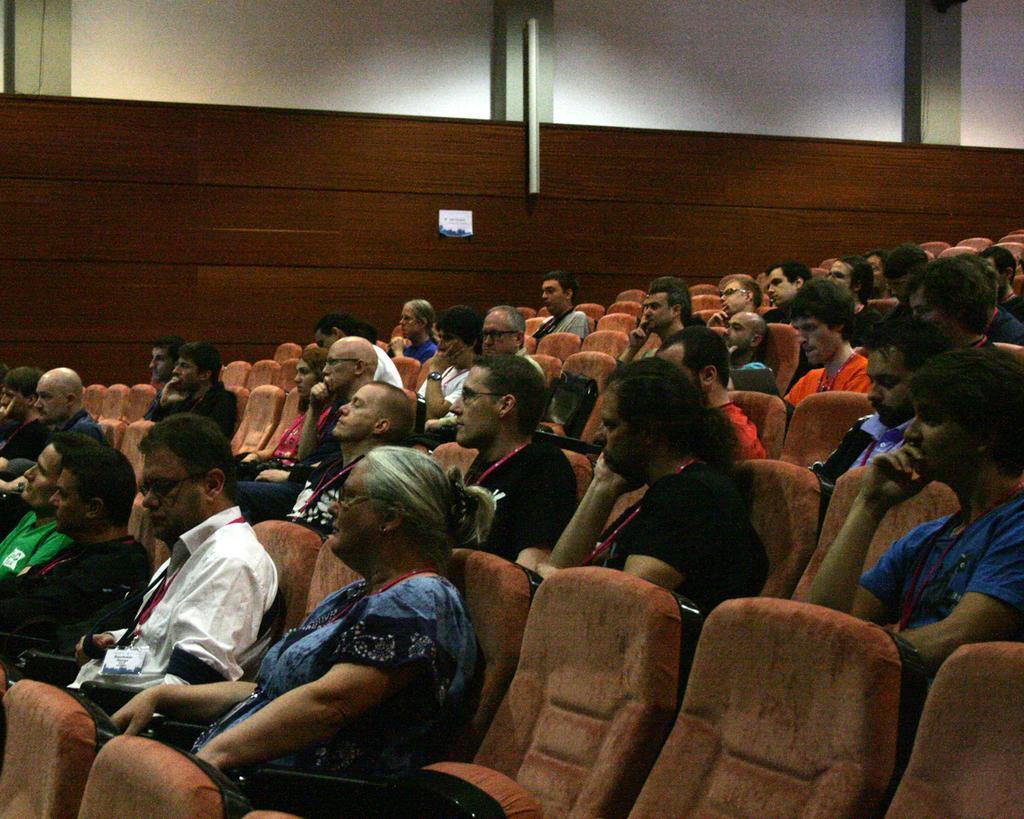In one or two sentences, can you explain what this image depicts? This image is taken inside the hall. In this image there are few people sitting in the chairs. In the background there is a wall on which there is a small label. There are so many chairs which are empty. 